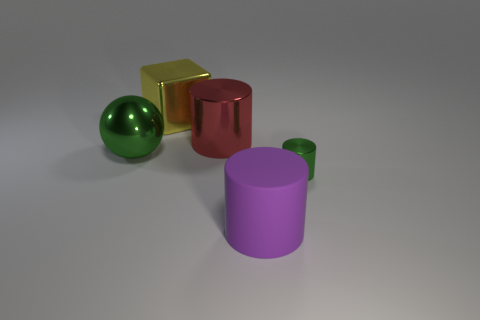Add 5 big red shiny things. How many objects exist? 10 Subtract all cylinders. How many objects are left? 2 Subtract all gray matte balls. Subtract all small green shiny cylinders. How many objects are left? 4 Add 5 large yellow shiny cubes. How many large yellow shiny cubes are left? 6 Add 5 large yellow metallic balls. How many large yellow metallic balls exist? 5 Subtract 1 red cylinders. How many objects are left? 4 